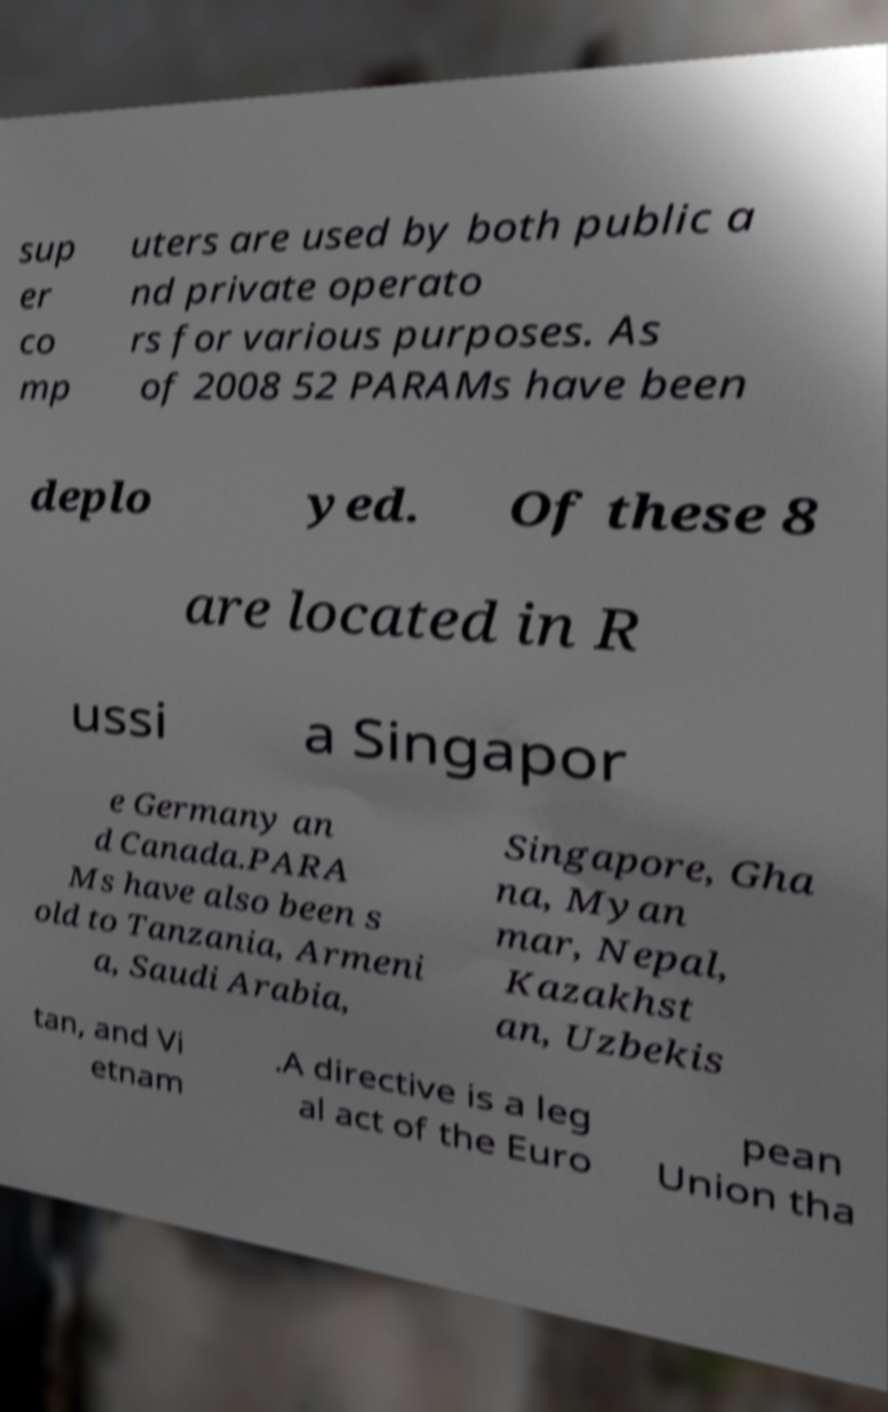Please identify and transcribe the text found in this image. sup er co mp uters are used by both public a nd private operato rs for various purposes. As of 2008 52 PARAMs have been deplo yed. Of these 8 are located in R ussi a Singapor e Germany an d Canada.PARA Ms have also been s old to Tanzania, Armeni a, Saudi Arabia, Singapore, Gha na, Myan mar, Nepal, Kazakhst an, Uzbekis tan, and Vi etnam .A directive is a leg al act of the Euro pean Union tha 